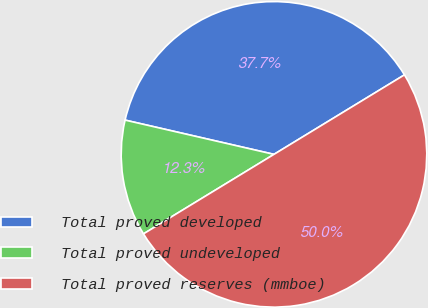Convert chart to OTSL. <chart><loc_0><loc_0><loc_500><loc_500><pie_chart><fcel>Total proved developed<fcel>Total proved undeveloped<fcel>Total proved reserves (mmboe)<nl><fcel>37.69%<fcel>12.31%<fcel>50.0%<nl></chart> 